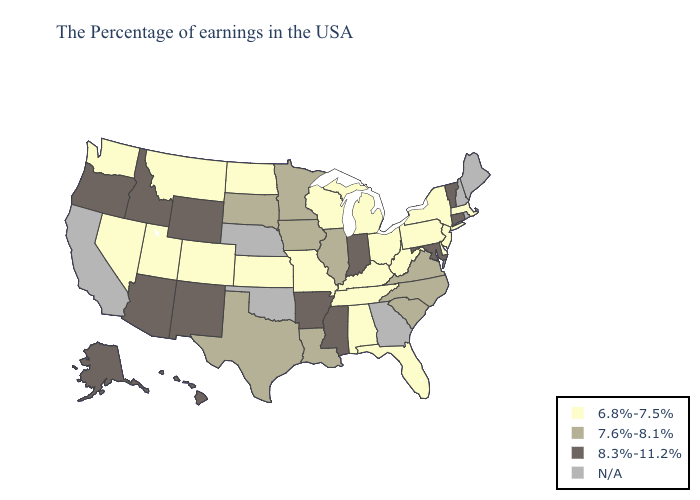Name the states that have a value in the range 7.6%-8.1%?
Give a very brief answer. Virginia, North Carolina, South Carolina, Illinois, Louisiana, Minnesota, Iowa, Texas, South Dakota. What is the highest value in the USA?
Give a very brief answer. 8.3%-11.2%. Name the states that have a value in the range 8.3%-11.2%?
Keep it brief. Vermont, Connecticut, Maryland, Indiana, Mississippi, Arkansas, Wyoming, New Mexico, Arizona, Idaho, Oregon, Alaska, Hawaii. What is the highest value in the Northeast ?
Be succinct. 8.3%-11.2%. What is the value of Idaho?
Answer briefly. 8.3%-11.2%. Which states have the lowest value in the USA?
Concise answer only. Massachusetts, New York, New Jersey, Delaware, Pennsylvania, West Virginia, Ohio, Florida, Michigan, Kentucky, Alabama, Tennessee, Wisconsin, Missouri, Kansas, North Dakota, Colorado, Utah, Montana, Nevada, Washington. Does Indiana have the lowest value in the MidWest?
Give a very brief answer. No. Does Arkansas have the highest value in the USA?
Keep it brief. Yes. What is the lowest value in the USA?
Be succinct. 6.8%-7.5%. What is the lowest value in the South?
Keep it brief. 6.8%-7.5%. Name the states that have a value in the range N/A?
Concise answer only. Maine, Rhode Island, New Hampshire, Georgia, Nebraska, Oklahoma, California. Which states hav the highest value in the West?
Concise answer only. Wyoming, New Mexico, Arizona, Idaho, Oregon, Alaska, Hawaii. What is the highest value in the Northeast ?
Be succinct. 8.3%-11.2%. 